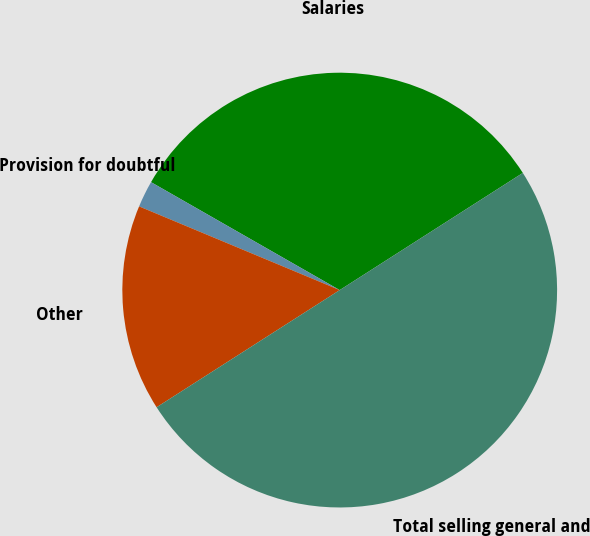<chart> <loc_0><loc_0><loc_500><loc_500><pie_chart><fcel>Salaries<fcel>Provision for doubtful<fcel>Other<fcel>Total selling general and<nl><fcel>32.67%<fcel>1.98%<fcel>15.35%<fcel>50.0%<nl></chart> 